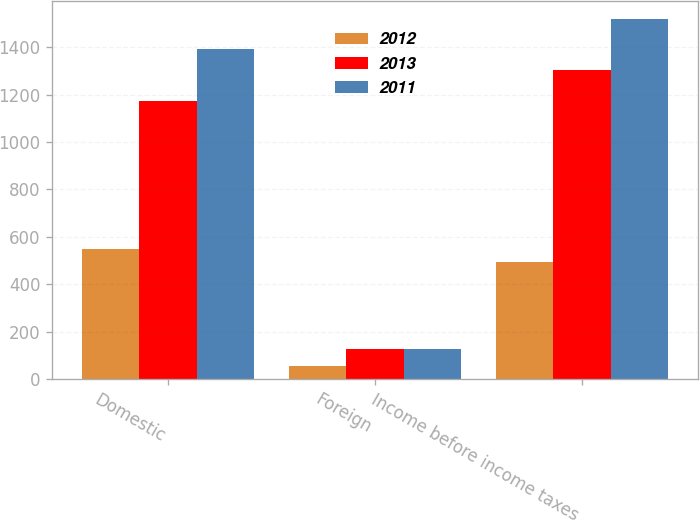<chart> <loc_0><loc_0><loc_500><loc_500><stacked_bar_chart><ecel><fcel>Domestic<fcel>Foreign<fcel>Income before income taxes<nl><fcel>2012<fcel>548<fcel>54<fcel>494<nl><fcel>2013<fcel>1175<fcel>128<fcel>1303<nl><fcel>2011<fcel>1394<fcel>126<fcel>1520<nl></chart> 